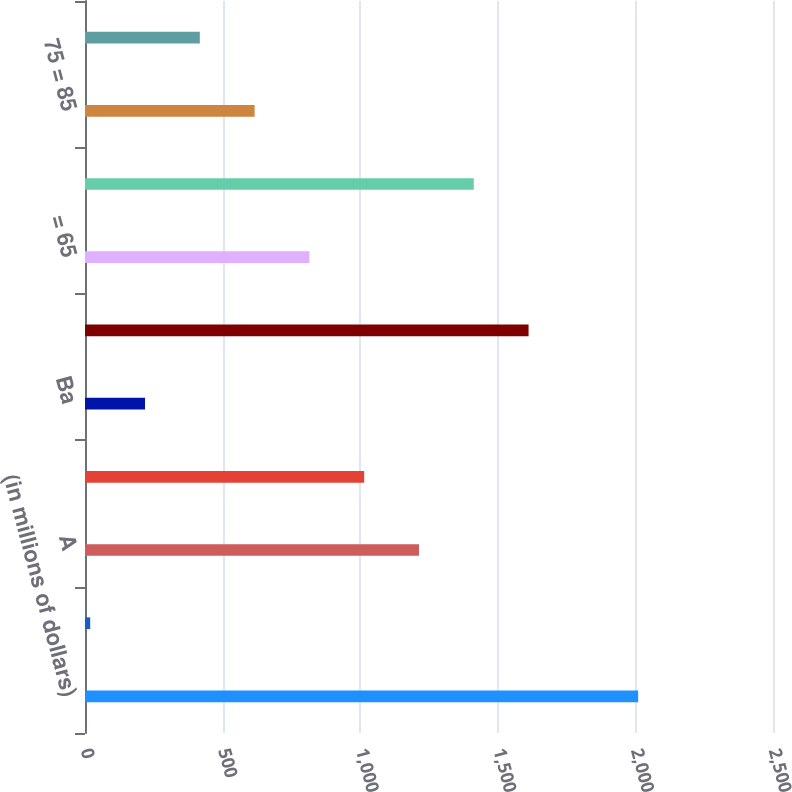Convert chart. <chart><loc_0><loc_0><loc_500><loc_500><bar_chart><fcel>(in millions of dollars)<fcel>Aa<fcel>A<fcel>Baa<fcel>Ba<fcel>Total<fcel>= 65<fcel>65 = 75<fcel>75 = 85<fcel>85 = 100<nl><fcel>2010<fcel>19<fcel>1213.6<fcel>1014.5<fcel>218.1<fcel>1611.8<fcel>815.4<fcel>1412.7<fcel>616.3<fcel>417.2<nl></chart> 